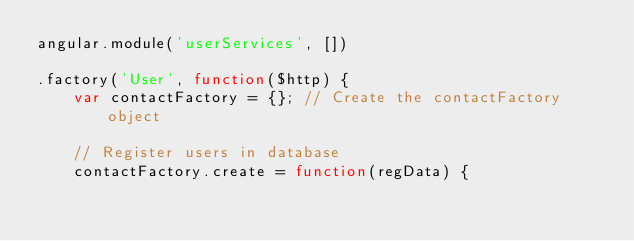Convert code to text. <code><loc_0><loc_0><loc_500><loc_500><_JavaScript_>angular.module('userServices', [])

.factory('User', function($http) {
    var contactFactory = {}; // Create the contactFactory object

    // Register users in database
    contactFactory.create = function(regData) {</code> 